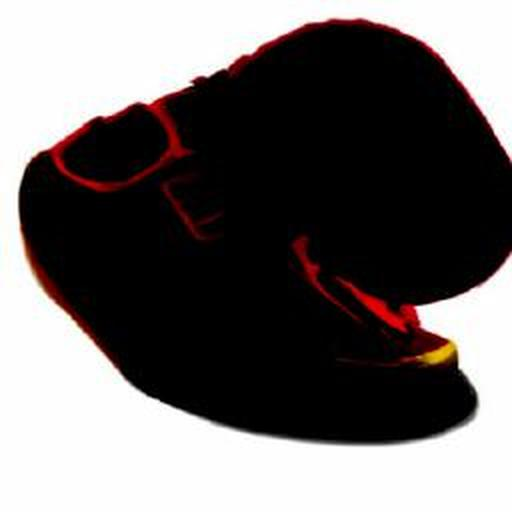Could this image represent a certain mood or theme, given its dark tones and indistinct shapes? The dark and ambiguous nature of the image might evoke a sense of mystery or suspense. It could represent a theme of uncertainty or the unknown, as its lack of distinct forms leaves much to the interpretation of the viewer. 